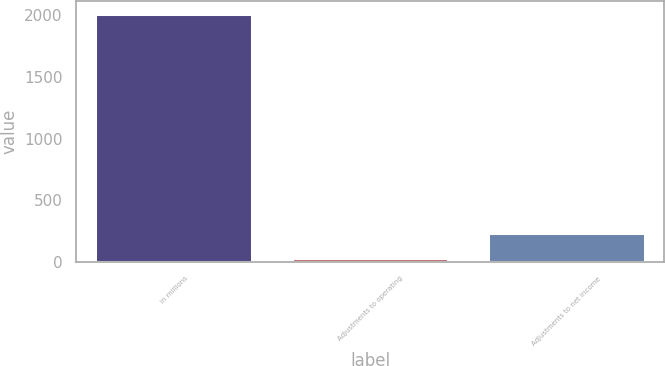<chart> <loc_0><loc_0><loc_500><loc_500><bar_chart><fcel>in millions<fcel>Adjustments to operating<fcel>Adjustments to net income<nl><fcel>2012<fcel>35.6<fcel>233.24<nl></chart> 